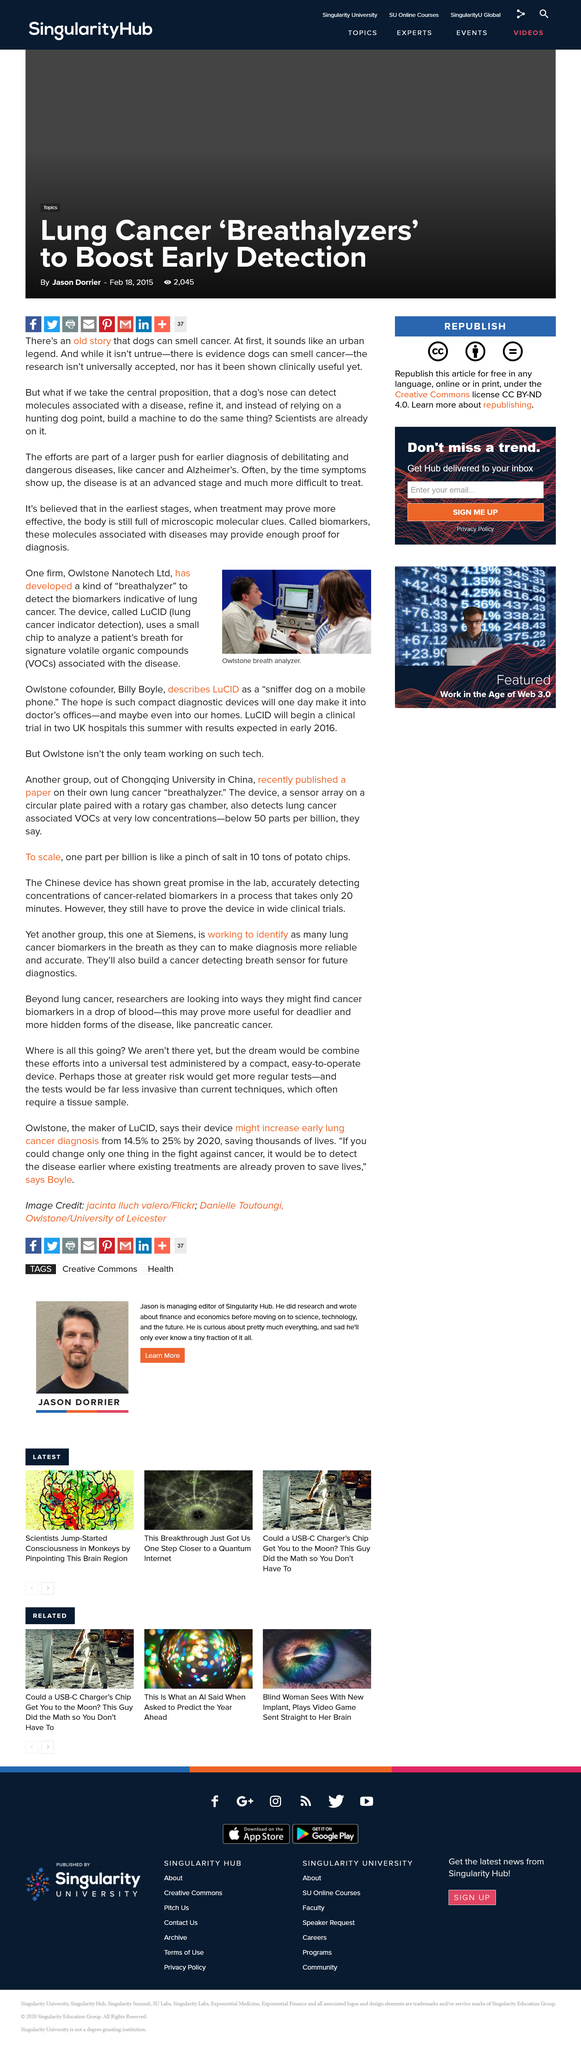Outline some significant characteristics in this image. The name of the device is LuCID. The Breathalyzer is a diagnostic tool that detects the presence of biomarkers associated with lung cancer, providing a non-invasive and accurate means of identifying the disease in its early stages. Chongqing University recently published a paper on the same research as another group. 